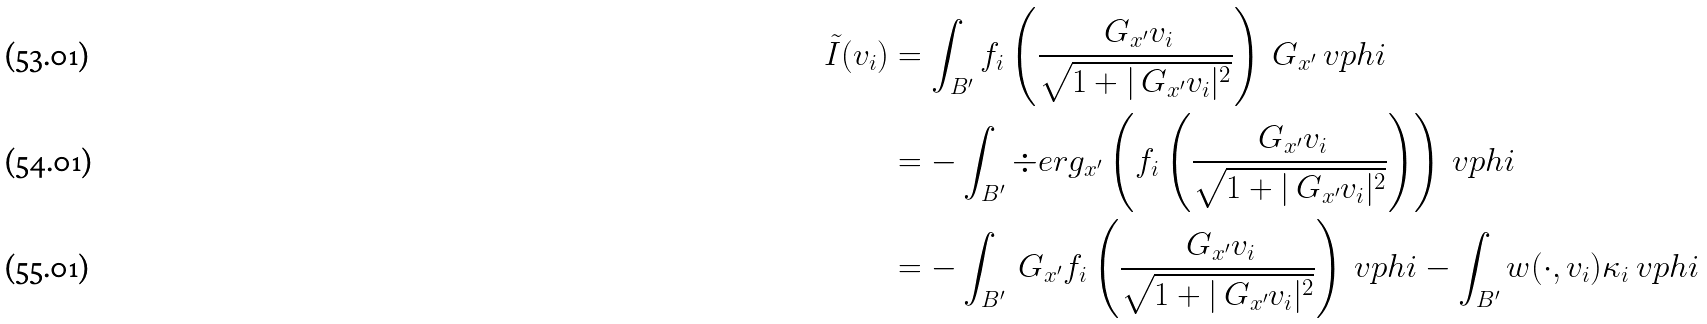Convert formula to latex. <formula><loc_0><loc_0><loc_500><loc_500>\tilde { I } ( v _ { i } ) & = \int _ { B ^ { \prime } } f _ { i } \left ( { \frac { \ G _ { x ^ { \prime } } v _ { i } } { \sqrt { 1 + | \ G _ { x ^ { \prime } } v _ { i } | ^ { 2 } } } } \right ) \ G _ { x ^ { \prime } } \ v p h i \\ & = - \int _ { B ^ { \prime } } \div e r g _ { x ^ { \prime } } \left ( f _ { i } \left ( { \frac { \ G _ { x ^ { \prime } } v _ { i } } { \sqrt { 1 + | \ G _ { x ^ { \prime } } v _ { i } | ^ { 2 } } } } \right ) \right ) \ v p h i \\ & = - \int _ { B ^ { \prime } } \ G _ { x ^ { \prime } } f _ { i } \left ( { \frac { \ G _ { x ^ { \prime } } v _ { i } } { \sqrt { 1 + | \ G _ { x ^ { \prime } } v _ { i } | ^ { 2 } } } } \right ) \ v p h i - \int _ { B ^ { \prime } } w ( \cdot , v _ { i } ) \kappa _ { i } \ v p h i</formula> 